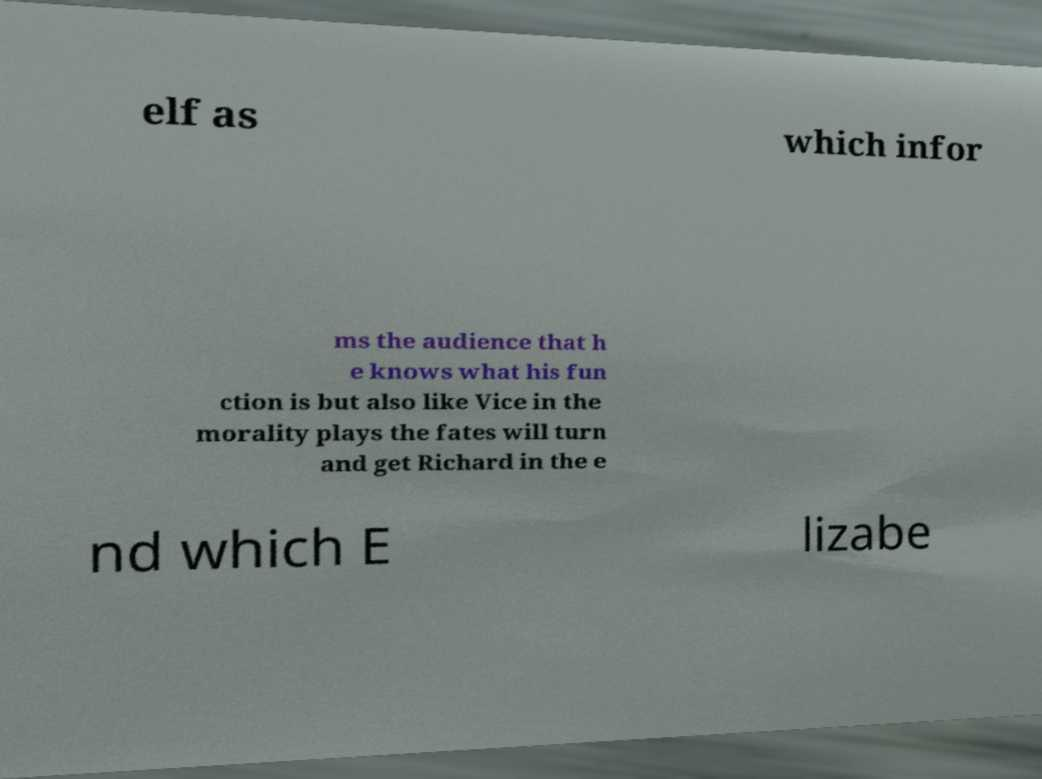Please identify and transcribe the text found in this image. elf as which infor ms the audience that h e knows what his fun ction is but also like Vice in the morality plays the fates will turn and get Richard in the e nd which E lizabe 